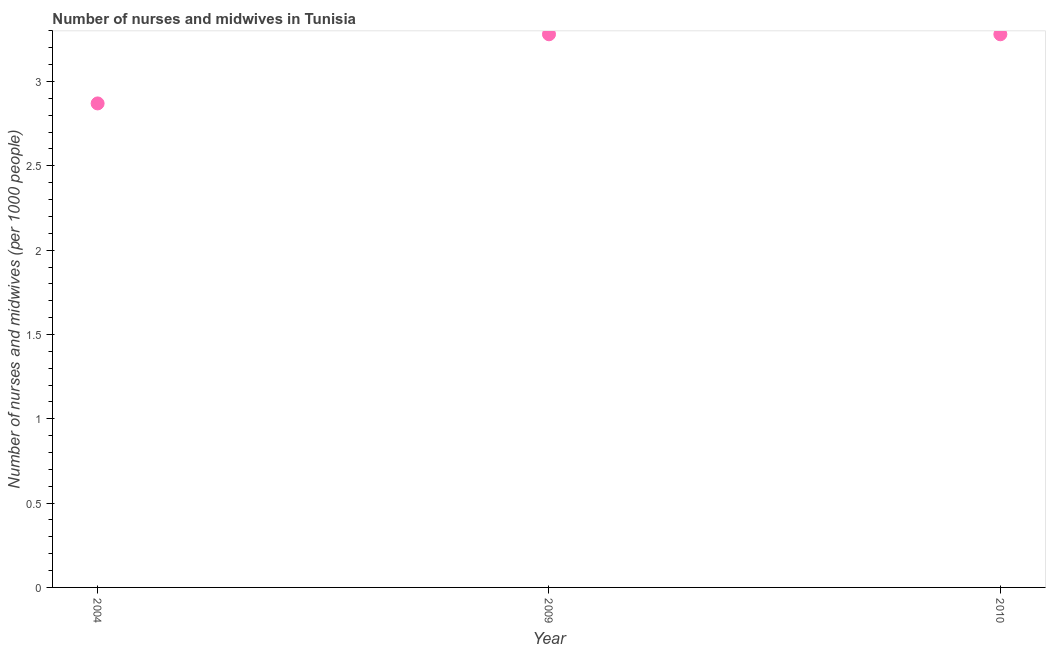What is the number of nurses and midwives in 2004?
Offer a very short reply. 2.87. Across all years, what is the maximum number of nurses and midwives?
Make the answer very short. 3.28. Across all years, what is the minimum number of nurses and midwives?
Make the answer very short. 2.87. In which year was the number of nurses and midwives maximum?
Ensure brevity in your answer.  2009. In which year was the number of nurses and midwives minimum?
Offer a very short reply. 2004. What is the sum of the number of nurses and midwives?
Provide a short and direct response. 9.43. What is the difference between the number of nurses and midwives in 2004 and 2009?
Ensure brevity in your answer.  -0.41. What is the average number of nurses and midwives per year?
Offer a terse response. 3.14. What is the median number of nurses and midwives?
Provide a short and direct response. 3.28. In how many years, is the number of nurses and midwives greater than 1.2 ?
Give a very brief answer. 3. Do a majority of the years between 2009 and 2004 (inclusive) have number of nurses and midwives greater than 1.6 ?
Keep it short and to the point. No. What is the ratio of the number of nurses and midwives in 2004 to that in 2009?
Your response must be concise. 0.88. Is the number of nurses and midwives in 2004 less than that in 2010?
Your answer should be very brief. Yes. Is the difference between the number of nurses and midwives in 2009 and 2010 greater than the difference between any two years?
Ensure brevity in your answer.  No. What is the difference between the highest and the second highest number of nurses and midwives?
Your answer should be very brief. 0. Is the sum of the number of nurses and midwives in 2004 and 2009 greater than the maximum number of nurses and midwives across all years?
Offer a very short reply. Yes. What is the difference between the highest and the lowest number of nurses and midwives?
Make the answer very short. 0.41. Does the number of nurses and midwives monotonically increase over the years?
Your answer should be compact. No. How many dotlines are there?
Give a very brief answer. 1. How many years are there in the graph?
Offer a terse response. 3. Are the values on the major ticks of Y-axis written in scientific E-notation?
Ensure brevity in your answer.  No. What is the title of the graph?
Make the answer very short. Number of nurses and midwives in Tunisia. What is the label or title of the X-axis?
Your response must be concise. Year. What is the label or title of the Y-axis?
Offer a very short reply. Number of nurses and midwives (per 1000 people). What is the Number of nurses and midwives (per 1000 people) in 2004?
Provide a succinct answer. 2.87. What is the Number of nurses and midwives (per 1000 people) in 2009?
Ensure brevity in your answer.  3.28. What is the Number of nurses and midwives (per 1000 people) in 2010?
Ensure brevity in your answer.  3.28. What is the difference between the Number of nurses and midwives (per 1000 people) in 2004 and 2009?
Provide a short and direct response. -0.41. What is the difference between the Number of nurses and midwives (per 1000 people) in 2004 and 2010?
Your answer should be compact. -0.41. What is the ratio of the Number of nurses and midwives (per 1000 people) in 2004 to that in 2009?
Make the answer very short. 0.88. What is the ratio of the Number of nurses and midwives (per 1000 people) in 2009 to that in 2010?
Offer a terse response. 1. 